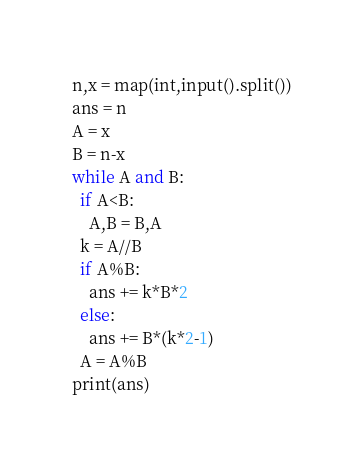Convert code to text. <code><loc_0><loc_0><loc_500><loc_500><_Python_>n,x = map(int,input().split())
ans = n
A = x
B = n-x
while A and B:
  if A<B:
    A,B = B,A
  k = A//B
  if A%B:
    ans += k*B*2
  else:
    ans += B*(k*2-1)
  A = A%B
print(ans)</code> 